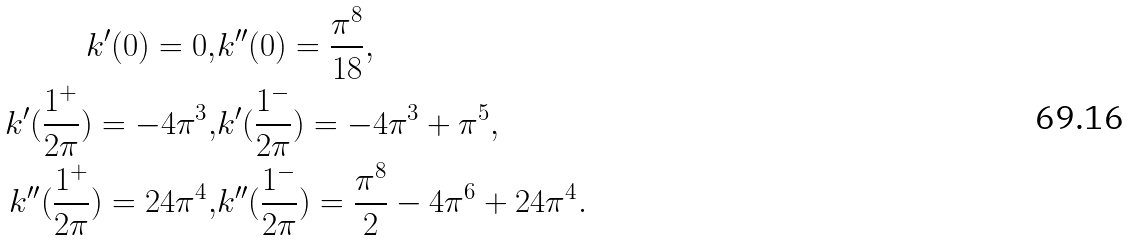<formula> <loc_0><loc_0><loc_500><loc_500>k ^ { \prime } ( 0 ) = 0 , & k ^ { \prime \prime } ( 0 ) = \frac { \pi ^ { 8 } } { 1 8 } , \\ k ^ { \prime } ( \frac { 1 ^ { + } } { 2 \pi } ) = - 4 \pi ^ { 3 } , & k ^ { \prime } ( \frac { 1 ^ { - } } { 2 \pi } ) = - 4 \pi ^ { 3 } + \pi ^ { 5 } , \\ k ^ { \prime \prime } ( \frac { 1 ^ { + } } { 2 \pi } ) = 2 4 \pi ^ { 4 } , & k ^ { \prime \prime } ( \frac { 1 ^ { - } } { 2 \pi } ) = \frac { \pi ^ { 8 } } { 2 } - 4 \pi ^ { 6 } + 2 4 \pi ^ { 4 } .</formula> 